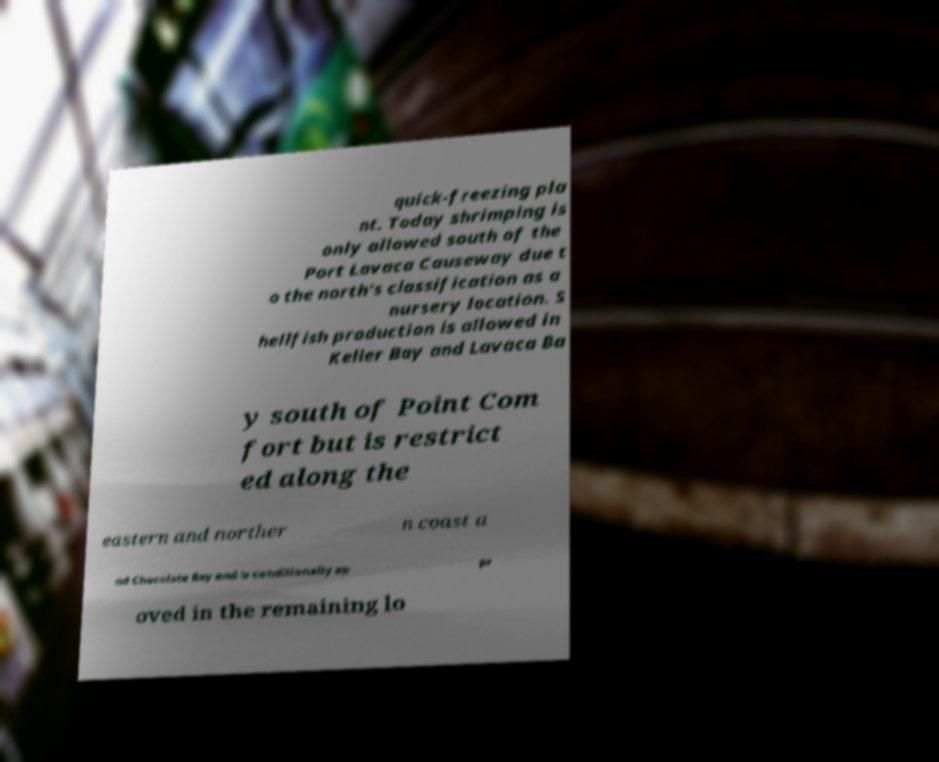What messages or text are displayed in this image? I need them in a readable, typed format. quick-freezing pla nt. Today shrimping is only allowed south of the Port Lavaca Causeway due t o the north's classification as a nursery location. S hellfish production is allowed in Keller Bay and Lavaca Ba y south of Point Com fort but is restrict ed along the eastern and norther n coast a nd Chocolate Bay and is conditionally ap pr oved in the remaining lo 